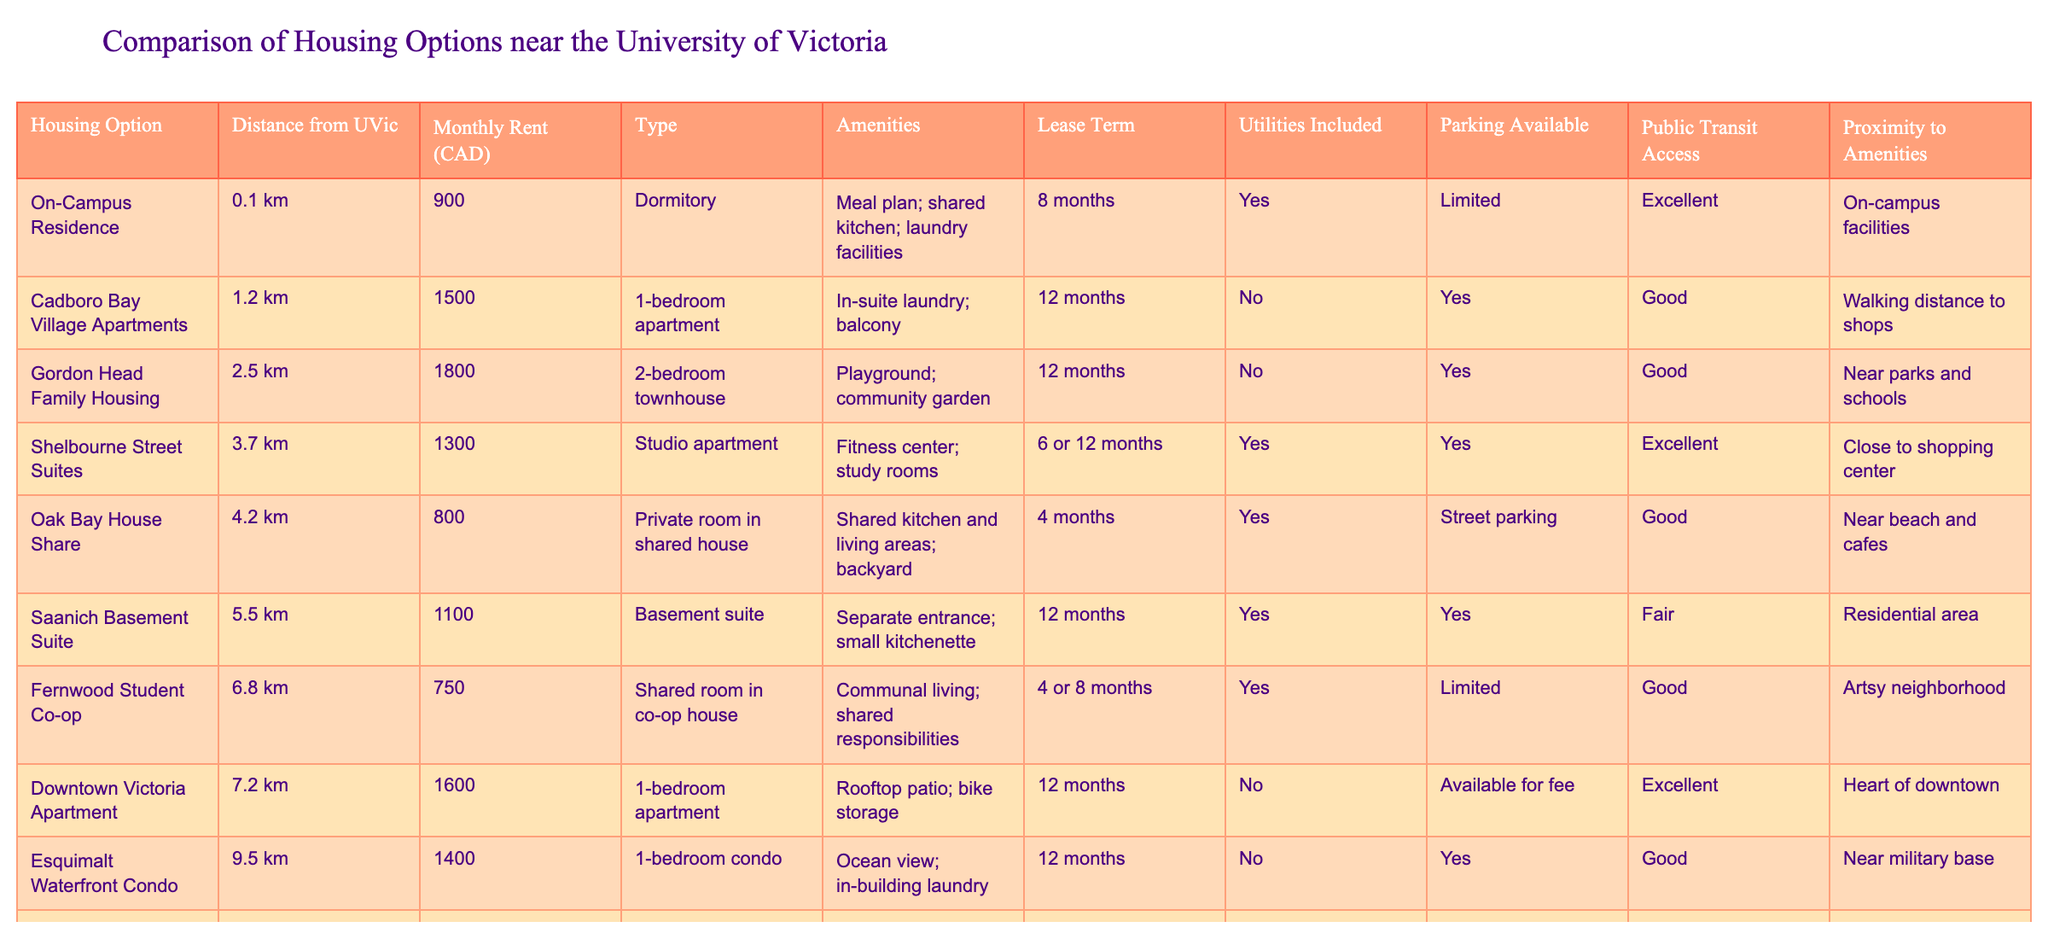What is the distance from the Cadboro Bay Village Apartments to UVic? The distance from Cadboro Bay Village Apartments to UVic is listed in the table under the "Distance from UVic" column, which states it is 1.2 km.
Answer: 1.2 km What amenities are provided in the On-Campus Residence? The amenities for the On-Campus Residence can be found in the "Amenities" column, which lists a meal plan, shared kitchen, and laundry facilities.
Answer: Meal plan; shared kitchen; laundry facilities Is parking available at the Gordon Head Family Housing? The "Parking Available" column indicates whether parking is available. For Gordon Head Family Housing, the entry is "Yes", confirming parking is available.
Answer: Yes Which housing option has the lowest monthly rent, and what is that amount? By looking at the "Monthly Rent" column, I can see that the lowest rent is found in the Fernwood Student Co-op at 750 CAD.
Answer: 750 CAD What is the average monthly rent for the apartments (1-bedroom and studio) listed in the table? First, identify the relevant rents: Cadboro Bay Village Apartments (1500), Downtown Victoria Apartment (1600), Shelbourne Street Suites (1300), and Esquimalt Waterfront Condo (1400). Summing these gives 1500 + 1600 + 1300 + 1400 = 5800. Dividing by 4 (the number of these apartments) gives an average of 1450 CAD.
Answer: 1450 CAD Are all housing options located within 6 km of UVic? To answer this, review the "Distance from UVic" column. Options like Saanich Basement Suite (5.5 km) and Fernwood Student Co-op (6.8 km) exceed 6 km, thus not all options are within this distance.
Answer: No Which option offers a lease term of 4 months? The lease terms are listed in the "Lease Term" column. Upon review, Oak Bay House Share and Fernwood Student Co-op both have lease terms of 4 months.
Answer: Oak Bay House Share, Fernwood Student Co-op What percentage of the housing options include utilities in the rent? First, count the total housing options, which is 9. Next, see how many have "Yes" for utilities included from the "Utilities Included" column: On-Campus Residence (Yes), Shelbourne Street Suites (Yes), Oak Bay House Share (Yes), Saanich Basement Suite (Yes), and Fernwood Student Co-op (Yes), which totals 5. Calculating the percentage gives (5/9)*100 = 55.56%.
Answer: 55.56% Which housing option is the farthest from UVic? Reviewing the "Distance from UVic" column reveals that Langford Budget Apartment at 15.3 km is the farthest listed option from UVic.
Answer: Langford Budget Apartment 